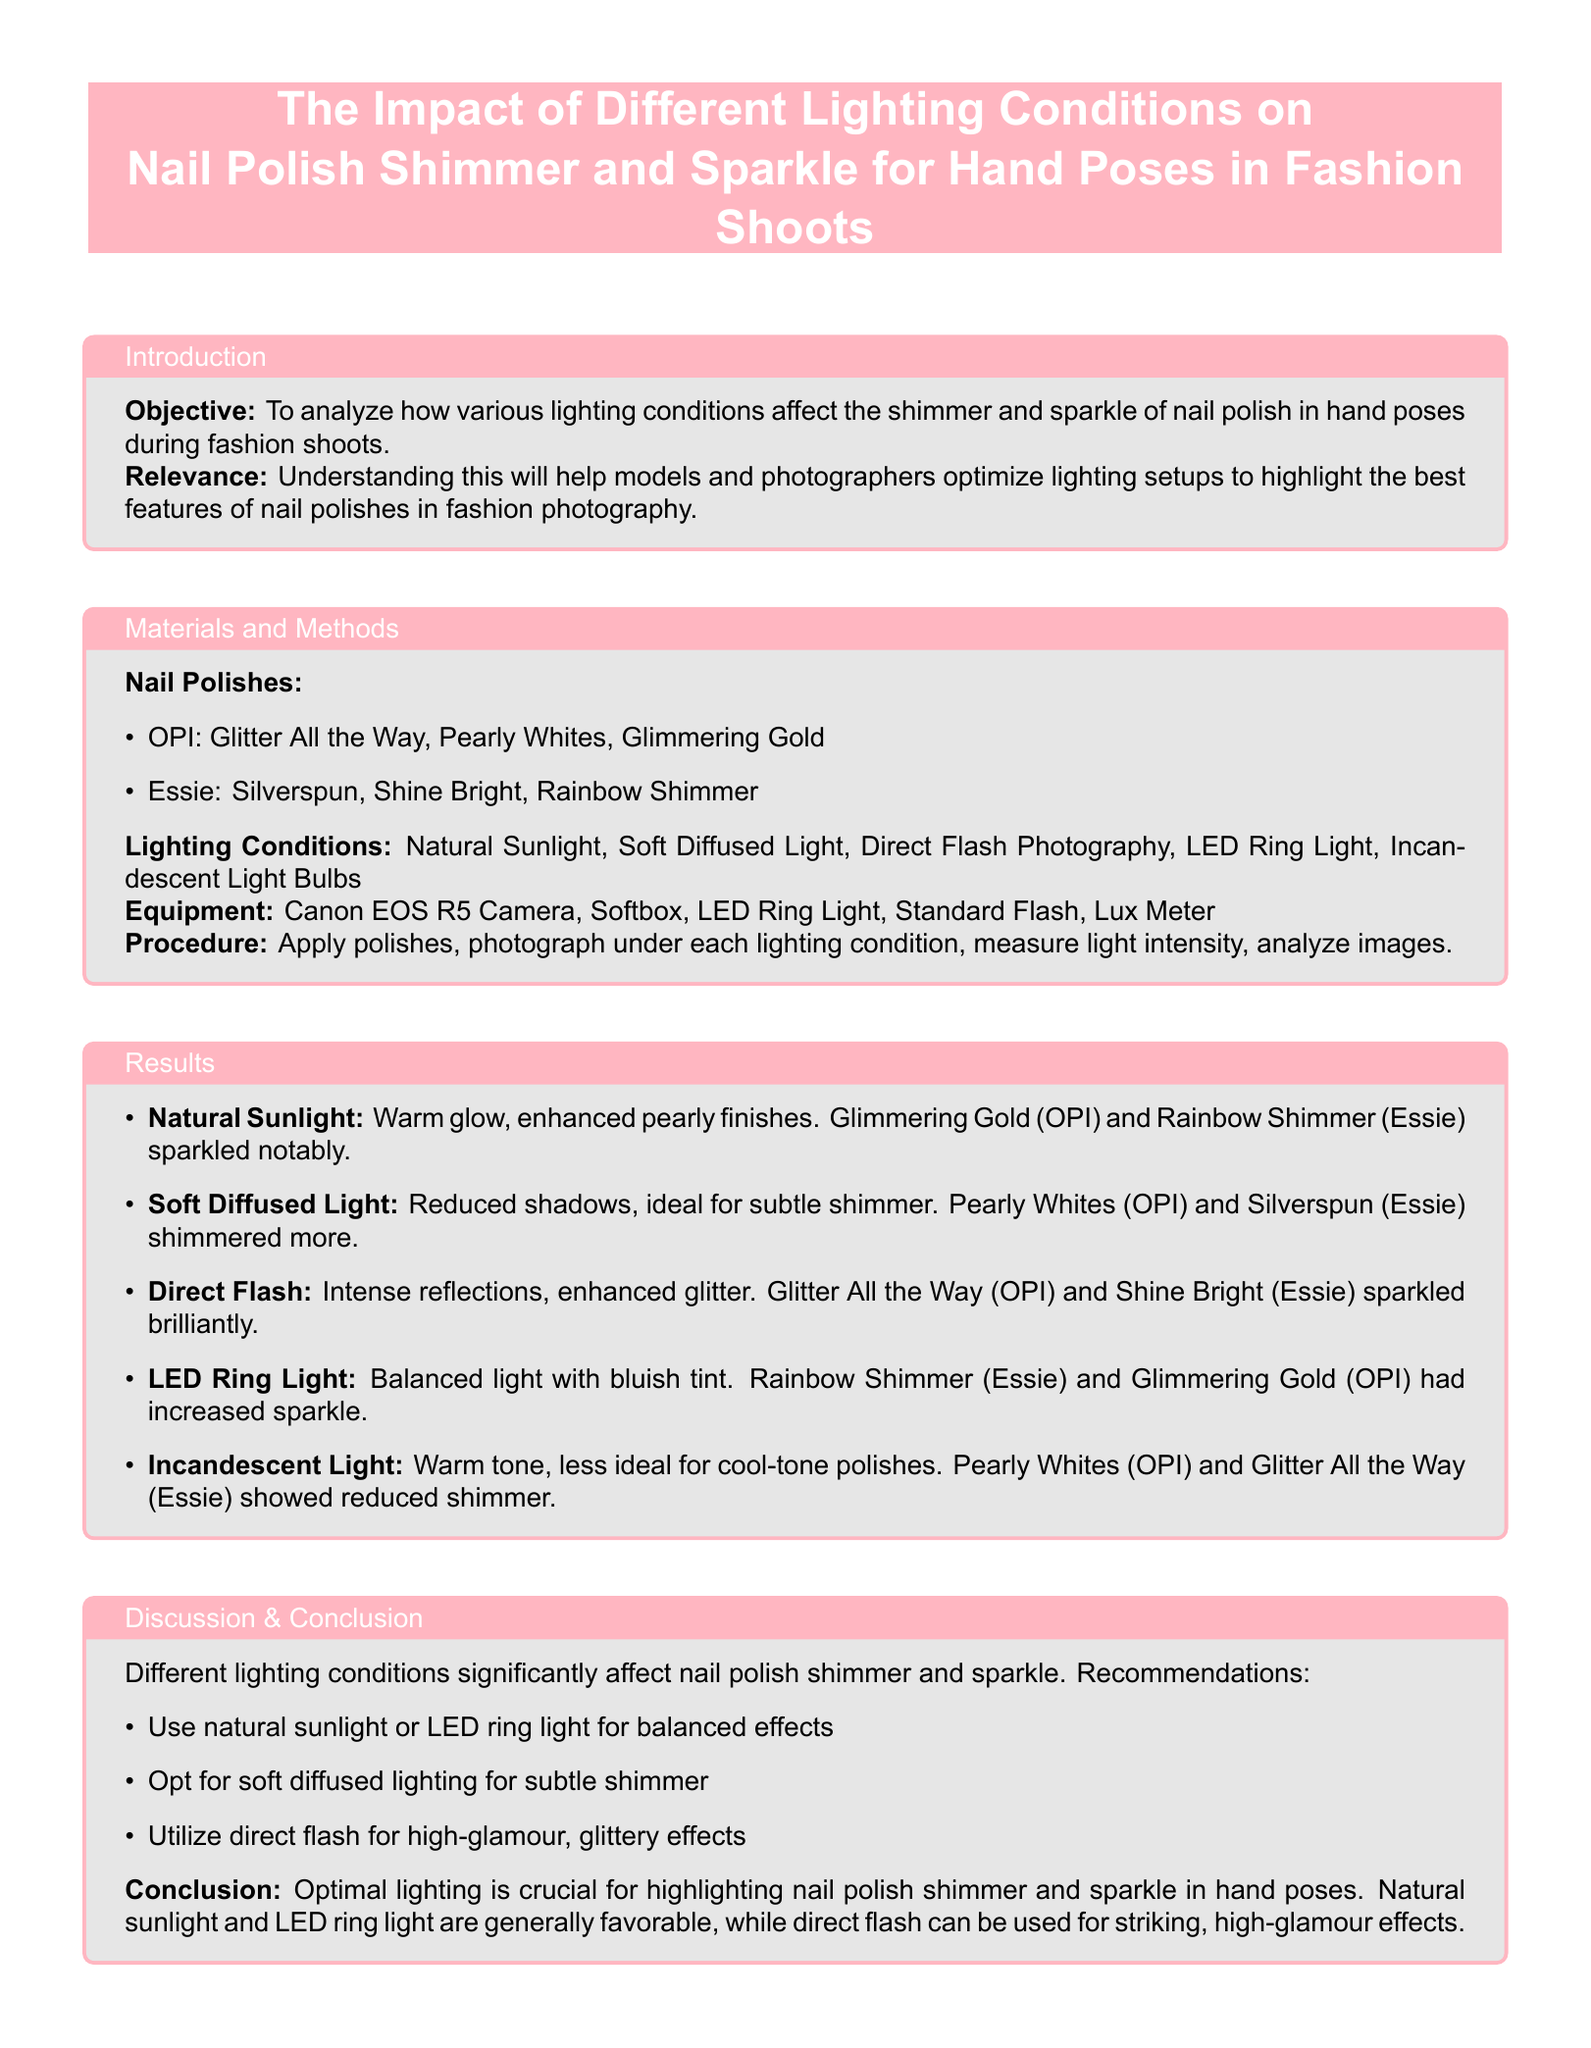What is the objective of the study? The objective of the study is to analyze how various lighting conditions affect the shimmer and sparkle of nail polish in hand poses during fashion shoots.
Answer: To analyze how various lighting conditions affect the shimmer and sparkle of nail polish in hand poses during fashion shoots What nail polish brand is used with the name "Glitter All the Way"? "Glitter All the Way" is a nail polish from the OPI brand.
Answer: OPI Which lighting condition enhances pearly finishes? The lighting condition that enhances pearly finishes is Natural Sunlight.
Answer: Natural Sunlight What is the recommended lighting condition for subtle shimmer? The recommended lighting condition for subtle shimmer is Soft Diffused Light.
Answer: Soft Diffused Light Which lighting condition provides intense reflections? The lighting condition that provides intense reflections is Direct Flash.
Answer: Direct Flash Which two nail polishes sparkled notably under natural sunlight? The two nail polishes that sparkled notably under natural sunlight are Glimmering Gold and Rainbow Shimmer.
Answer: Glimmering Gold and Rainbow Shimmer What is the conclusion regarding optimal lighting? The conclusion states that optimal lighting is crucial for highlighting nail polish shimmer and sparkle in hand poses.
Answer: Optimal lighting is crucial for highlighting nail polish shimmer and sparkle in hand poses How is LED ring light described in terms of its light effect? LED ring light is described as providing balanced light with a bluish tint.
Answer: Balanced light with bluish tint Which nail polish is less ideal under incandescent light? The nail polish that is less ideal under incandescent light is Pearly Whites.
Answer: Pearly Whites 